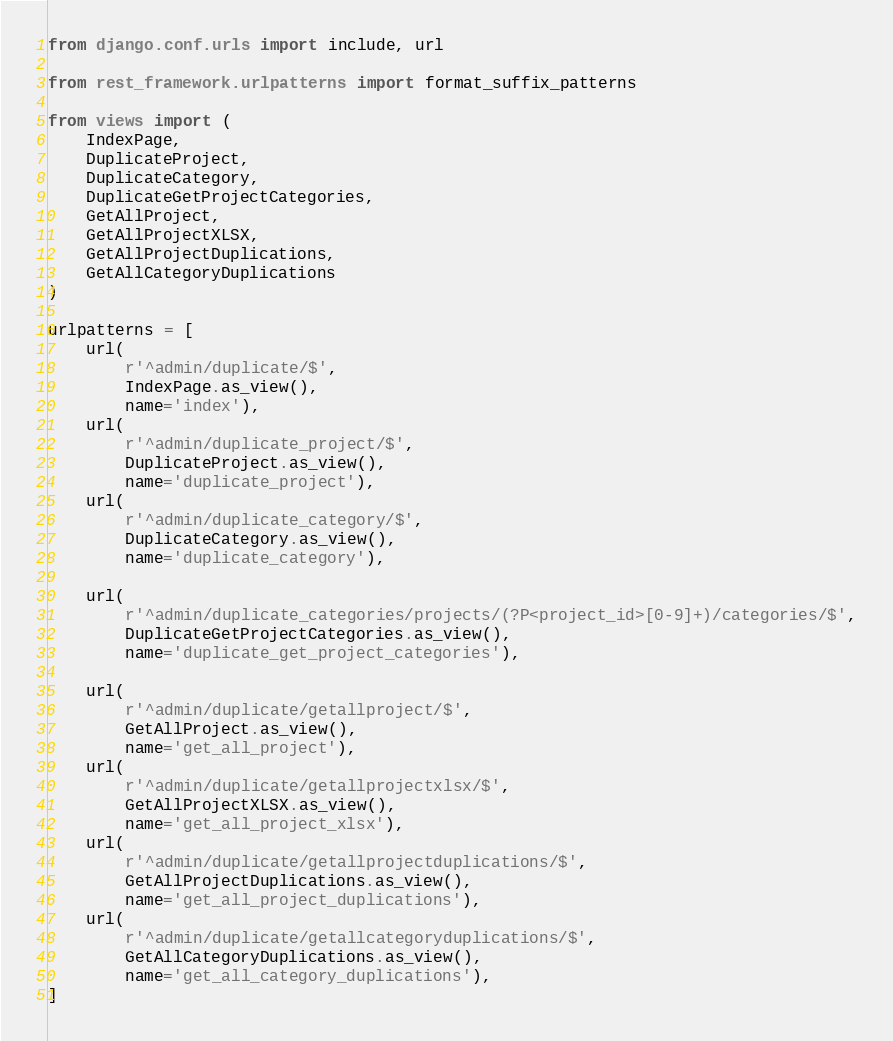<code> <loc_0><loc_0><loc_500><loc_500><_Python_>from django.conf.urls import include, url

from rest_framework.urlpatterns import format_suffix_patterns

from views import (
    IndexPage,
    DuplicateProject,
    DuplicateCategory,
    DuplicateGetProjectCategories,
    GetAllProject,
    GetAllProjectXLSX,
    GetAllProjectDuplications,
    GetAllCategoryDuplications
)

urlpatterns = [
    url(
        r'^admin/duplicate/$',
        IndexPage.as_view(),
        name='index'),
    url(
        r'^admin/duplicate_project/$',
        DuplicateProject.as_view(),
        name='duplicate_project'),
    url(
        r'^admin/duplicate_category/$',
        DuplicateCategory.as_view(),
        name='duplicate_category'),

    url(
        r'^admin/duplicate_categories/projects/(?P<project_id>[0-9]+)/categories/$',
        DuplicateGetProjectCategories.as_view(),
        name='duplicate_get_project_categories'),

    url(
        r'^admin/duplicate/getallproject/$',
        GetAllProject.as_view(),
        name='get_all_project'),
    url(
        r'^admin/duplicate/getallprojectxlsx/$',
        GetAllProjectXLSX.as_view(),
        name='get_all_project_xlsx'),
    url(
        r'^admin/duplicate/getallprojectduplications/$',
        GetAllProjectDuplications.as_view(),
        name='get_all_project_duplications'),
    url(
        r'^admin/duplicate/getallcategoryduplications/$',
        GetAllCategoryDuplications.as_view(),
        name='get_all_category_duplications'),
]
</code> 